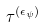Convert formula to latex. <formula><loc_0><loc_0><loc_500><loc_500>\tau ^ { ( \epsilon _ { \psi } ) }</formula> 